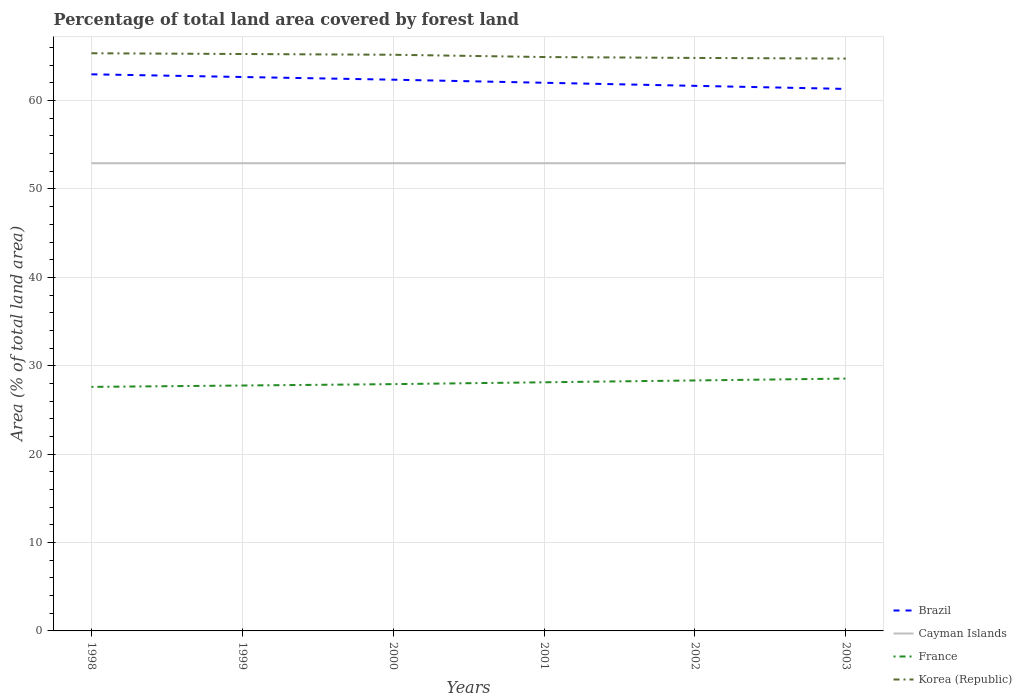How many different coloured lines are there?
Offer a terse response. 4. Is the number of lines equal to the number of legend labels?
Provide a short and direct response. Yes. Across all years, what is the maximum percentage of forest land in Brazil?
Ensure brevity in your answer.  61.32. What is the total percentage of forest land in Korea (Republic) in the graph?
Ensure brevity in your answer.  0.44. What is the difference between the highest and the second highest percentage of forest land in Korea (Republic)?
Provide a succinct answer. 0.6. What is the difference between the highest and the lowest percentage of forest land in France?
Your answer should be compact. 3. Are the values on the major ticks of Y-axis written in scientific E-notation?
Keep it short and to the point. No. How many legend labels are there?
Your response must be concise. 4. How are the legend labels stacked?
Offer a terse response. Vertical. What is the title of the graph?
Your response must be concise. Percentage of total land area covered by forest land. What is the label or title of the Y-axis?
Your answer should be compact. Area (% of total land area). What is the Area (% of total land area) of Brazil in 1998?
Provide a succinct answer. 62.98. What is the Area (% of total land area) in Cayman Islands in 1998?
Provide a short and direct response. 52.92. What is the Area (% of total land area) in France in 1998?
Your answer should be very brief. 27.61. What is the Area (% of total land area) in Korea (Republic) in 1998?
Your answer should be compact. 65.36. What is the Area (% of total land area) of Brazil in 1999?
Your answer should be very brief. 62.67. What is the Area (% of total land area) of Cayman Islands in 1999?
Offer a terse response. 52.92. What is the Area (% of total land area) in France in 1999?
Provide a succinct answer. 27.77. What is the Area (% of total land area) in Korea (Republic) in 1999?
Provide a short and direct response. 65.27. What is the Area (% of total land area) in Brazil in 2000?
Your response must be concise. 62.37. What is the Area (% of total land area) of Cayman Islands in 2000?
Make the answer very short. 52.92. What is the Area (% of total land area) of France in 2000?
Offer a very short reply. 27.92. What is the Area (% of total land area) of Korea (Republic) in 2000?
Make the answer very short. 65.19. What is the Area (% of total land area) in Brazil in 2001?
Offer a terse response. 62.02. What is the Area (% of total land area) of Cayman Islands in 2001?
Offer a very short reply. 52.92. What is the Area (% of total land area) of France in 2001?
Offer a very short reply. 28.13. What is the Area (% of total land area) of Korea (Republic) in 2001?
Provide a short and direct response. 64.93. What is the Area (% of total land area) of Brazil in 2002?
Keep it short and to the point. 61.67. What is the Area (% of total land area) in Cayman Islands in 2002?
Make the answer very short. 52.92. What is the Area (% of total land area) in France in 2002?
Provide a short and direct response. 28.34. What is the Area (% of total land area) of Korea (Republic) in 2002?
Your response must be concise. 64.83. What is the Area (% of total land area) in Brazil in 2003?
Your response must be concise. 61.32. What is the Area (% of total land area) of Cayman Islands in 2003?
Give a very brief answer. 52.92. What is the Area (% of total land area) in France in 2003?
Offer a very short reply. 28.55. What is the Area (% of total land area) in Korea (Republic) in 2003?
Give a very brief answer. 64.75. Across all years, what is the maximum Area (% of total land area) of Brazil?
Give a very brief answer. 62.98. Across all years, what is the maximum Area (% of total land area) of Cayman Islands?
Provide a short and direct response. 52.92. Across all years, what is the maximum Area (% of total land area) in France?
Your answer should be very brief. 28.55. Across all years, what is the maximum Area (% of total land area) in Korea (Republic)?
Give a very brief answer. 65.36. Across all years, what is the minimum Area (% of total land area) in Brazil?
Give a very brief answer. 61.32. Across all years, what is the minimum Area (% of total land area) in Cayman Islands?
Ensure brevity in your answer.  52.92. Across all years, what is the minimum Area (% of total land area) in France?
Your response must be concise. 27.61. Across all years, what is the minimum Area (% of total land area) of Korea (Republic)?
Make the answer very short. 64.75. What is the total Area (% of total land area) of Brazil in the graph?
Provide a succinct answer. 373.03. What is the total Area (% of total land area) of Cayman Islands in the graph?
Your response must be concise. 317.5. What is the total Area (% of total land area) in France in the graph?
Ensure brevity in your answer.  168.32. What is the total Area (% of total land area) in Korea (Republic) in the graph?
Offer a very short reply. 390.33. What is the difference between the Area (% of total land area) of Brazil in 1998 and that in 1999?
Make the answer very short. 0.3. What is the difference between the Area (% of total land area) of Cayman Islands in 1998 and that in 1999?
Your answer should be very brief. 0. What is the difference between the Area (% of total land area) in France in 1998 and that in 1999?
Make the answer very short. -0.16. What is the difference between the Area (% of total land area) in Korea (Republic) in 1998 and that in 1999?
Provide a succinct answer. 0.09. What is the difference between the Area (% of total land area) of Brazil in 1998 and that in 2000?
Keep it short and to the point. 0.61. What is the difference between the Area (% of total land area) in France in 1998 and that in 2000?
Provide a short and direct response. -0.31. What is the difference between the Area (% of total land area) of Korea (Republic) in 1998 and that in 2000?
Give a very brief answer. 0.17. What is the difference between the Area (% of total land area) in Brazil in 1998 and that in 2001?
Your answer should be very brief. 0.96. What is the difference between the Area (% of total land area) of Cayman Islands in 1998 and that in 2001?
Your answer should be very brief. 0. What is the difference between the Area (% of total land area) of France in 1998 and that in 2001?
Offer a very short reply. -0.52. What is the difference between the Area (% of total land area) in Korea (Republic) in 1998 and that in 2001?
Make the answer very short. 0.43. What is the difference between the Area (% of total land area) of Brazil in 1998 and that in 2002?
Offer a terse response. 1.3. What is the difference between the Area (% of total land area) of France in 1998 and that in 2002?
Give a very brief answer. -0.73. What is the difference between the Area (% of total land area) of Korea (Republic) in 1998 and that in 2002?
Provide a succinct answer. 0.53. What is the difference between the Area (% of total land area) in Brazil in 1998 and that in 2003?
Ensure brevity in your answer.  1.65. What is the difference between the Area (% of total land area) of France in 1998 and that in 2003?
Keep it short and to the point. -0.94. What is the difference between the Area (% of total land area) of Korea (Republic) in 1998 and that in 2003?
Keep it short and to the point. 0.6. What is the difference between the Area (% of total land area) of Brazil in 1999 and that in 2000?
Offer a terse response. 0.3. What is the difference between the Area (% of total land area) in France in 1999 and that in 2000?
Offer a terse response. -0.16. What is the difference between the Area (% of total land area) of Korea (Republic) in 1999 and that in 2000?
Your response must be concise. 0.09. What is the difference between the Area (% of total land area) in Brazil in 1999 and that in 2001?
Offer a terse response. 0.65. What is the difference between the Area (% of total land area) of Cayman Islands in 1999 and that in 2001?
Offer a terse response. 0. What is the difference between the Area (% of total land area) in France in 1999 and that in 2001?
Keep it short and to the point. -0.36. What is the difference between the Area (% of total land area) in Korea (Republic) in 1999 and that in 2001?
Offer a very short reply. 0.34. What is the difference between the Area (% of total land area) in Cayman Islands in 1999 and that in 2002?
Provide a short and direct response. 0. What is the difference between the Area (% of total land area) of France in 1999 and that in 2002?
Give a very brief answer. -0.57. What is the difference between the Area (% of total land area) in Korea (Republic) in 1999 and that in 2002?
Your answer should be very brief. 0.44. What is the difference between the Area (% of total land area) in Brazil in 1999 and that in 2003?
Give a very brief answer. 1.35. What is the difference between the Area (% of total land area) in France in 1999 and that in 2003?
Give a very brief answer. -0.78. What is the difference between the Area (% of total land area) in Korea (Republic) in 1999 and that in 2003?
Your answer should be very brief. 0.52. What is the difference between the Area (% of total land area) in Brazil in 2000 and that in 2001?
Offer a very short reply. 0.35. What is the difference between the Area (% of total land area) of Cayman Islands in 2000 and that in 2001?
Your response must be concise. 0. What is the difference between the Area (% of total land area) of France in 2000 and that in 2001?
Give a very brief answer. -0.21. What is the difference between the Area (% of total land area) of Korea (Republic) in 2000 and that in 2001?
Your response must be concise. 0.26. What is the difference between the Area (% of total land area) in Brazil in 2000 and that in 2002?
Your response must be concise. 0.7. What is the difference between the Area (% of total land area) of France in 2000 and that in 2002?
Ensure brevity in your answer.  -0.42. What is the difference between the Area (% of total land area) in Korea (Republic) in 2000 and that in 2002?
Your answer should be compact. 0.36. What is the difference between the Area (% of total land area) of Brazil in 2000 and that in 2003?
Your response must be concise. 1.04. What is the difference between the Area (% of total land area) of France in 2000 and that in 2003?
Keep it short and to the point. -0.63. What is the difference between the Area (% of total land area) in Korea (Republic) in 2000 and that in 2003?
Offer a very short reply. 0.43. What is the difference between the Area (% of total land area) in Brazil in 2001 and that in 2002?
Keep it short and to the point. 0.35. What is the difference between the Area (% of total land area) of France in 2001 and that in 2002?
Make the answer very short. -0.21. What is the difference between the Area (% of total land area) of Korea (Republic) in 2001 and that in 2002?
Provide a succinct answer. 0.1. What is the difference between the Area (% of total land area) of Brazil in 2001 and that in 2003?
Provide a succinct answer. 0.7. What is the difference between the Area (% of total land area) in France in 2001 and that in 2003?
Give a very brief answer. -0.42. What is the difference between the Area (% of total land area) in Korea (Republic) in 2001 and that in 2003?
Your answer should be compact. 0.18. What is the difference between the Area (% of total land area) of Brazil in 2002 and that in 2003?
Offer a very short reply. 0.35. What is the difference between the Area (% of total land area) in Cayman Islands in 2002 and that in 2003?
Your answer should be compact. 0. What is the difference between the Area (% of total land area) of France in 2002 and that in 2003?
Keep it short and to the point. -0.21. What is the difference between the Area (% of total land area) of Korea (Republic) in 2002 and that in 2003?
Give a very brief answer. 0.07. What is the difference between the Area (% of total land area) of Brazil in 1998 and the Area (% of total land area) of Cayman Islands in 1999?
Your response must be concise. 10.06. What is the difference between the Area (% of total land area) of Brazil in 1998 and the Area (% of total land area) of France in 1999?
Provide a succinct answer. 35.21. What is the difference between the Area (% of total land area) in Brazil in 1998 and the Area (% of total land area) in Korea (Republic) in 1999?
Your response must be concise. -2.3. What is the difference between the Area (% of total land area) of Cayman Islands in 1998 and the Area (% of total land area) of France in 1999?
Ensure brevity in your answer.  25.15. What is the difference between the Area (% of total land area) in Cayman Islands in 1998 and the Area (% of total land area) in Korea (Republic) in 1999?
Provide a succinct answer. -12.36. What is the difference between the Area (% of total land area) of France in 1998 and the Area (% of total land area) of Korea (Republic) in 1999?
Your answer should be very brief. -37.66. What is the difference between the Area (% of total land area) of Brazil in 1998 and the Area (% of total land area) of Cayman Islands in 2000?
Make the answer very short. 10.06. What is the difference between the Area (% of total land area) in Brazil in 1998 and the Area (% of total land area) in France in 2000?
Ensure brevity in your answer.  35.05. What is the difference between the Area (% of total land area) of Brazil in 1998 and the Area (% of total land area) of Korea (Republic) in 2000?
Offer a terse response. -2.21. What is the difference between the Area (% of total land area) in Cayman Islands in 1998 and the Area (% of total land area) in France in 2000?
Your response must be concise. 24.99. What is the difference between the Area (% of total land area) of Cayman Islands in 1998 and the Area (% of total land area) of Korea (Republic) in 2000?
Keep it short and to the point. -12.27. What is the difference between the Area (% of total land area) of France in 1998 and the Area (% of total land area) of Korea (Republic) in 2000?
Make the answer very short. -37.58. What is the difference between the Area (% of total land area) of Brazil in 1998 and the Area (% of total land area) of Cayman Islands in 2001?
Offer a terse response. 10.06. What is the difference between the Area (% of total land area) in Brazil in 1998 and the Area (% of total land area) in France in 2001?
Your response must be concise. 34.85. What is the difference between the Area (% of total land area) of Brazil in 1998 and the Area (% of total land area) of Korea (Republic) in 2001?
Offer a terse response. -1.96. What is the difference between the Area (% of total land area) of Cayman Islands in 1998 and the Area (% of total land area) of France in 2001?
Your answer should be very brief. 24.79. What is the difference between the Area (% of total land area) in Cayman Islands in 1998 and the Area (% of total land area) in Korea (Republic) in 2001?
Provide a short and direct response. -12.01. What is the difference between the Area (% of total land area) of France in 1998 and the Area (% of total land area) of Korea (Republic) in 2001?
Provide a succinct answer. -37.32. What is the difference between the Area (% of total land area) of Brazil in 1998 and the Area (% of total land area) of Cayman Islands in 2002?
Offer a terse response. 10.06. What is the difference between the Area (% of total land area) of Brazil in 1998 and the Area (% of total land area) of France in 2002?
Make the answer very short. 34.64. What is the difference between the Area (% of total land area) in Brazil in 1998 and the Area (% of total land area) in Korea (Republic) in 2002?
Make the answer very short. -1.85. What is the difference between the Area (% of total land area) in Cayman Islands in 1998 and the Area (% of total land area) in France in 2002?
Provide a short and direct response. 24.58. What is the difference between the Area (% of total land area) of Cayman Islands in 1998 and the Area (% of total land area) of Korea (Republic) in 2002?
Provide a succinct answer. -11.91. What is the difference between the Area (% of total land area) of France in 1998 and the Area (% of total land area) of Korea (Republic) in 2002?
Offer a very short reply. -37.22. What is the difference between the Area (% of total land area) of Brazil in 1998 and the Area (% of total land area) of Cayman Islands in 2003?
Keep it short and to the point. 10.06. What is the difference between the Area (% of total land area) of Brazil in 1998 and the Area (% of total land area) of France in 2003?
Provide a succinct answer. 34.43. What is the difference between the Area (% of total land area) of Brazil in 1998 and the Area (% of total land area) of Korea (Republic) in 2003?
Ensure brevity in your answer.  -1.78. What is the difference between the Area (% of total land area) in Cayman Islands in 1998 and the Area (% of total land area) in France in 2003?
Give a very brief answer. 24.37. What is the difference between the Area (% of total land area) of Cayman Islands in 1998 and the Area (% of total land area) of Korea (Republic) in 2003?
Your response must be concise. -11.84. What is the difference between the Area (% of total land area) in France in 1998 and the Area (% of total land area) in Korea (Republic) in 2003?
Ensure brevity in your answer.  -37.14. What is the difference between the Area (% of total land area) of Brazil in 1999 and the Area (% of total land area) of Cayman Islands in 2000?
Your answer should be compact. 9.75. What is the difference between the Area (% of total land area) in Brazil in 1999 and the Area (% of total land area) in France in 2000?
Your answer should be very brief. 34.75. What is the difference between the Area (% of total land area) in Brazil in 1999 and the Area (% of total land area) in Korea (Republic) in 2000?
Give a very brief answer. -2.52. What is the difference between the Area (% of total land area) in Cayman Islands in 1999 and the Area (% of total land area) in France in 2000?
Ensure brevity in your answer.  24.99. What is the difference between the Area (% of total land area) of Cayman Islands in 1999 and the Area (% of total land area) of Korea (Republic) in 2000?
Make the answer very short. -12.27. What is the difference between the Area (% of total land area) of France in 1999 and the Area (% of total land area) of Korea (Republic) in 2000?
Make the answer very short. -37.42. What is the difference between the Area (% of total land area) of Brazil in 1999 and the Area (% of total land area) of Cayman Islands in 2001?
Provide a succinct answer. 9.75. What is the difference between the Area (% of total land area) in Brazil in 1999 and the Area (% of total land area) in France in 2001?
Ensure brevity in your answer.  34.54. What is the difference between the Area (% of total land area) of Brazil in 1999 and the Area (% of total land area) of Korea (Republic) in 2001?
Your response must be concise. -2.26. What is the difference between the Area (% of total land area) of Cayman Islands in 1999 and the Area (% of total land area) of France in 2001?
Ensure brevity in your answer.  24.79. What is the difference between the Area (% of total land area) in Cayman Islands in 1999 and the Area (% of total land area) in Korea (Republic) in 2001?
Ensure brevity in your answer.  -12.01. What is the difference between the Area (% of total land area) in France in 1999 and the Area (% of total land area) in Korea (Republic) in 2001?
Your answer should be compact. -37.16. What is the difference between the Area (% of total land area) in Brazil in 1999 and the Area (% of total land area) in Cayman Islands in 2002?
Provide a short and direct response. 9.75. What is the difference between the Area (% of total land area) in Brazil in 1999 and the Area (% of total land area) in France in 2002?
Your answer should be compact. 34.33. What is the difference between the Area (% of total land area) in Brazil in 1999 and the Area (% of total land area) in Korea (Republic) in 2002?
Your answer should be compact. -2.16. What is the difference between the Area (% of total land area) of Cayman Islands in 1999 and the Area (% of total land area) of France in 2002?
Provide a short and direct response. 24.58. What is the difference between the Area (% of total land area) of Cayman Islands in 1999 and the Area (% of total land area) of Korea (Republic) in 2002?
Keep it short and to the point. -11.91. What is the difference between the Area (% of total land area) in France in 1999 and the Area (% of total land area) in Korea (Republic) in 2002?
Ensure brevity in your answer.  -37.06. What is the difference between the Area (% of total land area) in Brazil in 1999 and the Area (% of total land area) in Cayman Islands in 2003?
Ensure brevity in your answer.  9.75. What is the difference between the Area (% of total land area) in Brazil in 1999 and the Area (% of total land area) in France in 2003?
Your answer should be very brief. 34.12. What is the difference between the Area (% of total land area) of Brazil in 1999 and the Area (% of total land area) of Korea (Republic) in 2003?
Offer a very short reply. -2.08. What is the difference between the Area (% of total land area) of Cayman Islands in 1999 and the Area (% of total land area) of France in 2003?
Give a very brief answer. 24.37. What is the difference between the Area (% of total land area) in Cayman Islands in 1999 and the Area (% of total land area) in Korea (Republic) in 2003?
Your answer should be very brief. -11.84. What is the difference between the Area (% of total land area) in France in 1999 and the Area (% of total land area) in Korea (Republic) in 2003?
Give a very brief answer. -36.99. What is the difference between the Area (% of total land area) in Brazil in 2000 and the Area (% of total land area) in Cayman Islands in 2001?
Give a very brief answer. 9.45. What is the difference between the Area (% of total land area) of Brazil in 2000 and the Area (% of total land area) of France in 2001?
Your answer should be compact. 34.24. What is the difference between the Area (% of total land area) of Brazil in 2000 and the Area (% of total land area) of Korea (Republic) in 2001?
Give a very brief answer. -2.56. What is the difference between the Area (% of total land area) in Cayman Islands in 2000 and the Area (% of total land area) in France in 2001?
Your answer should be compact. 24.79. What is the difference between the Area (% of total land area) of Cayman Islands in 2000 and the Area (% of total land area) of Korea (Republic) in 2001?
Your response must be concise. -12.01. What is the difference between the Area (% of total land area) of France in 2000 and the Area (% of total land area) of Korea (Republic) in 2001?
Your answer should be compact. -37.01. What is the difference between the Area (% of total land area) of Brazil in 2000 and the Area (% of total land area) of Cayman Islands in 2002?
Your answer should be compact. 9.45. What is the difference between the Area (% of total land area) of Brazil in 2000 and the Area (% of total land area) of France in 2002?
Your response must be concise. 34.03. What is the difference between the Area (% of total land area) of Brazil in 2000 and the Area (% of total land area) of Korea (Republic) in 2002?
Your answer should be very brief. -2.46. What is the difference between the Area (% of total land area) in Cayman Islands in 2000 and the Area (% of total land area) in France in 2002?
Ensure brevity in your answer.  24.58. What is the difference between the Area (% of total land area) in Cayman Islands in 2000 and the Area (% of total land area) in Korea (Republic) in 2002?
Ensure brevity in your answer.  -11.91. What is the difference between the Area (% of total land area) of France in 2000 and the Area (% of total land area) of Korea (Republic) in 2002?
Offer a terse response. -36.91. What is the difference between the Area (% of total land area) in Brazil in 2000 and the Area (% of total land area) in Cayman Islands in 2003?
Provide a succinct answer. 9.45. What is the difference between the Area (% of total land area) in Brazil in 2000 and the Area (% of total land area) in France in 2003?
Your answer should be compact. 33.82. What is the difference between the Area (% of total land area) of Brazil in 2000 and the Area (% of total land area) of Korea (Republic) in 2003?
Your response must be concise. -2.39. What is the difference between the Area (% of total land area) in Cayman Islands in 2000 and the Area (% of total land area) in France in 2003?
Ensure brevity in your answer.  24.37. What is the difference between the Area (% of total land area) of Cayman Islands in 2000 and the Area (% of total land area) of Korea (Republic) in 2003?
Your answer should be compact. -11.84. What is the difference between the Area (% of total land area) of France in 2000 and the Area (% of total land area) of Korea (Republic) in 2003?
Ensure brevity in your answer.  -36.83. What is the difference between the Area (% of total land area) of Brazil in 2001 and the Area (% of total land area) of Cayman Islands in 2002?
Ensure brevity in your answer.  9.1. What is the difference between the Area (% of total land area) in Brazil in 2001 and the Area (% of total land area) in France in 2002?
Your answer should be very brief. 33.68. What is the difference between the Area (% of total land area) of Brazil in 2001 and the Area (% of total land area) of Korea (Republic) in 2002?
Your answer should be compact. -2.81. What is the difference between the Area (% of total land area) in Cayman Islands in 2001 and the Area (% of total land area) in France in 2002?
Your response must be concise. 24.58. What is the difference between the Area (% of total land area) of Cayman Islands in 2001 and the Area (% of total land area) of Korea (Republic) in 2002?
Your answer should be compact. -11.91. What is the difference between the Area (% of total land area) of France in 2001 and the Area (% of total land area) of Korea (Republic) in 2002?
Your response must be concise. -36.7. What is the difference between the Area (% of total land area) in Brazil in 2001 and the Area (% of total land area) in Cayman Islands in 2003?
Your answer should be compact. 9.1. What is the difference between the Area (% of total land area) of Brazil in 2001 and the Area (% of total land area) of France in 2003?
Offer a terse response. 33.47. What is the difference between the Area (% of total land area) in Brazil in 2001 and the Area (% of total land area) in Korea (Republic) in 2003?
Give a very brief answer. -2.73. What is the difference between the Area (% of total land area) in Cayman Islands in 2001 and the Area (% of total land area) in France in 2003?
Keep it short and to the point. 24.37. What is the difference between the Area (% of total land area) in Cayman Islands in 2001 and the Area (% of total land area) in Korea (Republic) in 2003?
Ensure brevity in your answer.  -11.84. What is the difference between the Area (% of total land area) of France in 2001 and the Area (% of total land area) of Korea (Republic) in 2003?
Your answer should be very brief. -36.62. What is the difference between the Area (% of total land area) of Brazil in 2002 and the Area (% of total land area) of Cayman Islands in 2003?
Offer a very short reply. 8.75. What is the difference between the Area (% of total land area) in Brazil in 2002 and the Area (% of total land area) in France in 2003?
Your answer should be very brief. 33.12. What is the difference between the Area (% of total land area) in Brazil in 2002 and the Area (% of total land area) in Korea (Republic) in 2003?
Your answer should be very brief. -3.08. What is the difference between the Area (% of total land area) in Cayman Islands in 2002 and the Area (% of total land area) in France in 2003?
Provide a succinct answer. 24.37. What is the difference between the Area (% of total land area) in Cayman Islands in 2002 and the Area (% of total land area) in Korea (Republic) in 2003?
Keep it short and to the point. -11.84. What is the difference between the Area (% of total land area) in France in 2002 and the Area (% of total land area) in Korea (Republic) in 2003?
Your response must be concise. -36.41. What is the average Area (% of total land area) in Brazil per year?
Offer a very short reply. 62.17. What is the average Area (% of total land area) of Cayman Islands per year?
Provide a succinct answer. 52.92. What is the average Area (% of total land area) in France per year?
Your response must be concise. 28.05. What is the average Area (% of total land area) in Korea (Republic) per year?
Offer a terse response. 65.06. In the year 1998, what is the difference between the Area (% of total land area) in Brazil and Area (% of total land area) in Cayman Islands?
Keep it short and to the point. 10.06. In the year 1998, what is the difference between the Area (% of total land area) of Brazil and Area (% of total land area) of France?
Your answer should be very brief. 35.37. In the year 1998, what is the difference between the Area (% of total land area) in Brazil and Area (% of total land area) in Korea (Republic)?
Offer a terse response. -2.38. In the year 1998, what is the difference between the Area (% of total land area) in Cayman Islands and Area (% of total land area) in France?
Provide a succinct answer. 25.31. In the year 1998, what is the difference between the Area (% of total land area) of Cayman Islands and Area (% of total land area) of Korea (Republic)?
Keep it short and to the point. -12.44. In the year 1998, what is the difference between the Area (% of total land area) of France and Area (% of total land area) of Korea (Republic)?
Your answer should be very brief. -37.75. In the year 1999, what is the difference between the Area (% of total land area) in Brazil and Area (% of total land area) in Cayman Islands?
Provide a short and direct response. 9.75. In the year 1999, what is the difference between the Area (% of total land area) of Brazil and Area (% of total land area) of France?
Provide a succinct answer. 34.91. In the year 1999, what is the difference between the Area (% of total land area) in Brazil and Area (% of total land area) in Korea (Republic)?
Keep it short and to the point. -2.6. In the year 1999, what is the difference between the Area (% of total land area) of Cayman Islands and Area (% of total land area) of France?
Give a very brief answer. 25.15. In the year 1999, what is the difference between the Area (% of total land area) of Cayman Islands and Area (% of total land area) of Korea (Republic)?
Keep it short and to the point. -12.36. In the year 1999, what is the difference between the Area (% of total land area) of France and Area (% of total land area) of Korea (Republic)?
Make the answer very short. -37.51. In the year 2000, what is the difference between the Area (% of total land area) of Brazil and Area (% of total land area) of Cayman Islands?
Offer a terse response. 9.45. In the year 2000, what is the difference between the Area (% of total land area) in Brazil and Area (% of total land area) in France?
Offer a terse response. 34.45. In the year 2000, what is the difference between the Area (% of total land area) of Brazil and Area (% of total land area) of Korea (Republic)?
Offer a terse response. -2.82. In the year 2000, what is the difference between the Area (% of total land area) in Cayman Islands and Area (% of total land area) in France?
Provide a short and direct response. 24.99. In the year 2000, what is the difference between the Area (% of total land area) in Cayman Islands and Area (% of total land area) in Korea (Republic)?
Ensure brevity in your answer.  -12.27. In the year 2000, what is the difference between the Area (% of total land area) in France and Area (% of total land area) in Korea (Republic)?
Offer a very short reply. -37.27. In the year 2001, what is the difference between the Area (% of total land area) in Brazil and Area (% of total land area) in Cayman Islands?
Your answer should be very brief. 9.1. In the year 2001, what is the difference between the Area (% of total land area) in Brazil and Area (% of total land area) in France?
Offer a very short reply. 33.89. In the year 2001, what is the difference between the Area (% of total land area) in Brazil and Area (% of total land area) in Korea (Republic)?
Your answer should be very brief. -2.91. In the year 2001, what is the difference between the Area (% of total land area) of Cayman Islands and Area (% of total land area) of France?
Ensure brevity in your answer.  24.79. In the year 2001, what is the difference between the Area (% of total land area) in Cayman Islands and Area (% of total land area) in Korea (Republic)?
Give a very brief answer. -12.01. In the year 2001, what is the difference between the Area (% of total land area) in France and Area (% of total land area) in Korea (Republic)?
Provide a succinct answer. -36.8. In the year 2002, what is the difference between the Area (% of total land area) of Brazil and Area (% of total land area) of Cayman Islands?
Keep it short and to the point. 8.75. In the year 2002, what is the difference between the Area (% of total land area) of Brazil and Area (% of total land area) of France?
Keep it short and to the point. 33.33. In the year 2002, what is the difference between the Area (% of total land area) in Brazil and Area (% of total land area) in Korea (Republic)?
Offer a very short reply. -3.16. In the year 2002, what is the difference between the Area (% of total land area) of Cayman Islands and Area (% of total land area) of France?
Keep it short and to the point. 24.58. In the year 2002, what is the difference between the Area (% of total land area) of Cayman Islands and Area (% of total land area) of Korea (Republic)?
Provide a succinct answer. -11.91. In the year 2002, what is the difference between the Area (% of total land area) in France and Area (% of total land area) in Korea (Republic)?
Give a very brief answer. -36.49. In the year 2003, what is the difference between the Area (% of total land area) in Brazil and Area (% of total land area) in Cayman Islands?
Provide a succinct answer. 8.41. In the year 2003, what is the difference between the Area (% of total land area) of Brazil and Area (% of total land area) of France?
Offer a terse response. 32.77. In the year 2003, what is the difference between the Area (% of total land area) of Brazil and Area (% of total land area) of Korea (Republic)?
Your answer should be very brief. -3.43. In the year 2003, what is the difference between the Area (% of total land area) in Cayman Islands and Area (% of total land area) in France?
Give a very brief answer. 24.37. In the year 2003, what is the difference between the Area (% of total land area) of Cayman Islands and Area (% of total land area) of Korea (Republic)?
Your response must be concise. -11.84. In the year 2003, what is the difference between the Area (% of total land area) in France and Area (% of total land area) in Korea (Republic)?
Offer a very short reply. -36.21. What is the ratio of the Area (% of total land area) of France in 1998 to that in 1999?
Provide a short and direct response. 0.99. What is the ratio of the Area (% of total land area) in Brazil in 1998 to that in 2000?
Provide a short and direct response. 1.01. What is the ratio of the Area (% of total land area) in Cayman Islands in 1998 to that in 2000?
Provide a succinct answer. 1. What is the ratio of the Area (% of total land area) of France in 1998 to that in 2000?
Keep it short and to the point. 0.99. What is the ratio of the Area (% of total land area) of Korea (Republic) in 1998 to that in 2000?
Your response must be concise. 1. What is the ratio of the Area (% of total land area) in Brazil in 1998 to that in 2001?
Provide a succinct answer. 1.02. What is the ratio of the Area (% of total land area) in Cayman Islands in 1998 to that in 2001?
Keep it short and to the point. 1. What is the ratio of the Area (% of total land area) in France in 1998 to that in 2001?
Your answer should be very brief. 0.98. What is the ratio of the Area (% of total land area) in Korea (Republic) in 1998 to that in 2001?
Provide a succinct answer. 1.01. What is the ratio of the Area (% of total land area) in Brazil in 1998 to that in 2002?
Your answer should be very brief. 1.02. What is the ratio of the Area (% of total land area) of France in 1998 to that in 2002?
Your response must be concise. 0.97. What is the ratio of the Area (% of total land area) of Korea (Republic) in 1998 to that in 2002?
Give a very brief answer. 1.01. What is the ratio of the Area (% of total land area) of Brazil in 1998 to that in 2003?
Ensure brevity in your answer.  1.03. What is the ratio of the Area (% of total land area) of France in 1998 to that in 2003?
Give a very brief answer. 0.97. What is the ratio of the Area (% of total land area) in Korea (Republic) in 1998 to that in 2003?
Provide a succinct answer. 1.01. What is the ratio of the Area (% of total land area) of Cayman Islands in 1999 to that in 2000?
Keep it short and to the point. 1. What is the ratio of the Area (% of total land area) of France in 1999 to that in 2000?
Your answer should be very brief. 0.99. What is the ratio of the Area (% of total land area) in Korea (Republic) in 1999 to that in 2000?
Your response must be concise. 1. What is the ratio of the Area (% of total land area) in Brazil in 1999 to that in 2001?
Ensure brevity in your answer.  1.01. What is the ratio of the Area (% of total land area) of Cayman Islands in 1999 to that in 2001?
Offer a terse response. 1. What is the ratio of the Area (% of total land area) in Korea (Republic) in 1999 to that in 2001?
Make the answer very short. 1.01. What is the ratio of the Area (% of total land area) of Brazil in 1999 to that in 2002?
Ensure brevity in your answer.  1.02. What is the ratio of the Area (% of total land area) in France in 1999 to that in 2002?
Your answer should be compact. 0.98. What is the ratio of the Area (% of total land area) of Korea (Republic) in 1999 to that in 2002?
Your answer should be compact. 1.01. What is the ratio of the Area (% of total land area) in Cayman Islands in 1999 to that in 2003?
Your answer should be very brief. 1. What is the ratio of the Area (% of total land area) of France in 1999 to that in 2003?
Provide a short and direct response. 0.97. What is the ratio of the Area (% of total land area) in Korea (Republic) in 1999 to that in 2003?
Your response must be concise. 1.01. What is the ratio of the Area (% of total land area) of Brazil in 2000 to that in 2001?
Your answer should be compact. 1.01. What is the ratio of the Area (% of total land area) of France in 2000 to that in 2001?
Ensure brevity in your answer.  0.99. What is the ratio of the Area (% of total land area) in Brazil in 2000 to that in 2002?
Keep it short and to the point. 1.01. What is the ratio of the Area (% of total land area) of France in 2000 to that in 2002?
Ensure brevity in your answer.  0.99. What is the ratio of the Area (% of total land area) of Korea (Republic) in 2000 to that in 2002?
Your answer should be very brief. 1.01. What is the ratio of the Area (% of total land area) in Korea (Republic) in 2000 to that in 2003?
Your answer should be very brief. 1.01. What is the ratio of the Area (% of total land area) in Brazil in 2001 to that in 2002?
Provide a short and direct response. 1.01. What is the ratio of the Area (% of total land area) of Korea (Republic) in 2001 to that in 2002?
Your answer should be compact. 1. What is the ratio of the Area (% of total land area) in Brazil in 2001 to that in 2003?
Ensure brevity in your answer.  1.01. What is the ratio of the Area (% of total land area) of France in 2001 to that in 2003?
Provide a short and direct response. 0.99. What is the ratio of the Area (% of total land area) in Cayman Islands in 2002 to that in 2003?
Give a very brief answer. 1. What is the ratio of the Area (% of total land area) in France in 2002 to that in 2003?
Offer a very short reply. 0.99. What is the difference between the highest and the second highest Area (% of total land area) in Brazil?
Your answer should be compact. 0.3. What is the difference between the highest and the second highest Area (% of total land area) of France?
Offer a terse response. 0.21. What is the difference between the highest and the second highest Area (% of total land area) in Korea (Republic)?
Your answer should be very brief. 0.09. What is the difference between the highest and the lowest Area (% of total land area) of Brazil?
Your response must be concise. 1.65. What is the difference between the highest and the lowest Area (% of total land area) in Cayman Islands?
Provide a succinct answer. 0. What is the difference between the highest and the lowest Area (% of total land area) of France?
Offer a very short reply. 0.94. What is the difference between the highest and the lowest Area (% of total land area) of Korea (Republic)?
Offer a very short reply. 0.6. 